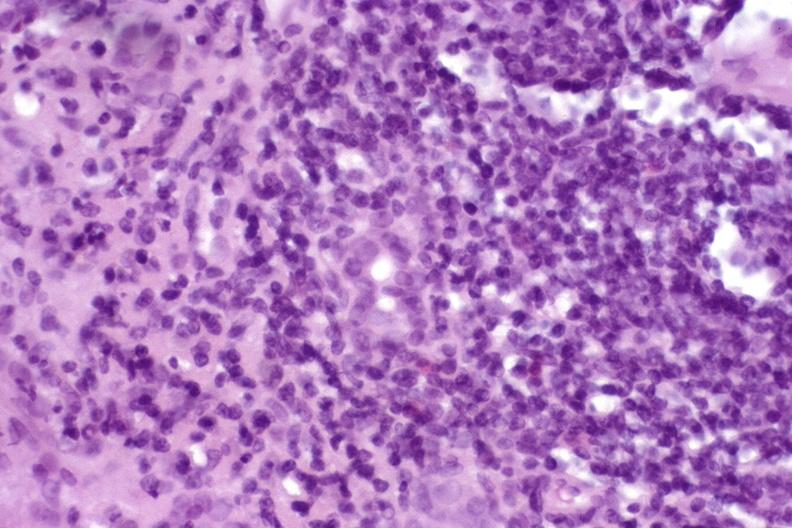s cervical carcinoma present?
Answer the question using a single word or phrase. No 